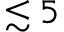<formula> <loc_0><loc_0><loc_500><loc_500>\lesssim 5</formula> 